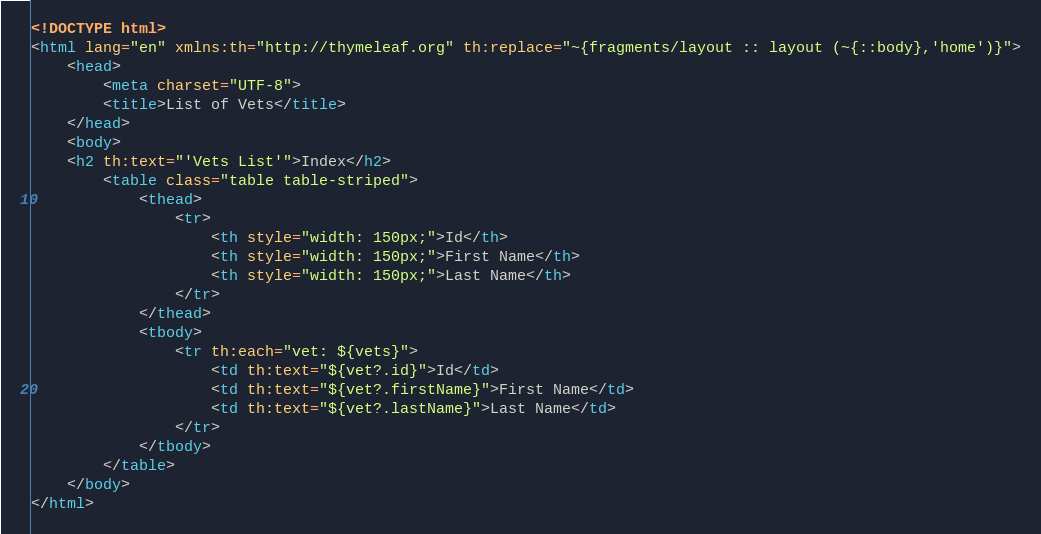<code> <loc_0><loc_0><loc_500><loc_500><_HTML_><!DOCTYPE html>
<html lang="en" xmlns:th="http://thymeleaf.org" th:replace="~{fragments/layout :: layout (~{::body},'home')}">
    <head>
        <meta charset="UTF-8">
        <title>List of Vets</title>
    </head>
    <body>
    <h2 th:text="'Vets List'">Index</h2>
        <table class="table table-striped">
            <thead>
                <tr>
                    <th style="width: 150px;">Id</th>
                    <th style="width: 150px;">First Name</th>
                    <th style="width: 150px;">Last Name</th>
                </tr>
            </thead>
            <tbody>
                <tr th:each="vet: ${vets}">
                    <td th:text="${vet?.id}">Id</td>
                    <td th:text="${vet?.firstName}">First Name</td>
                    <td th:text="${vet?.lastName}">Last Name</td>
                </tr>
            </tbody>
        </table>
    </body>
</html></code> 